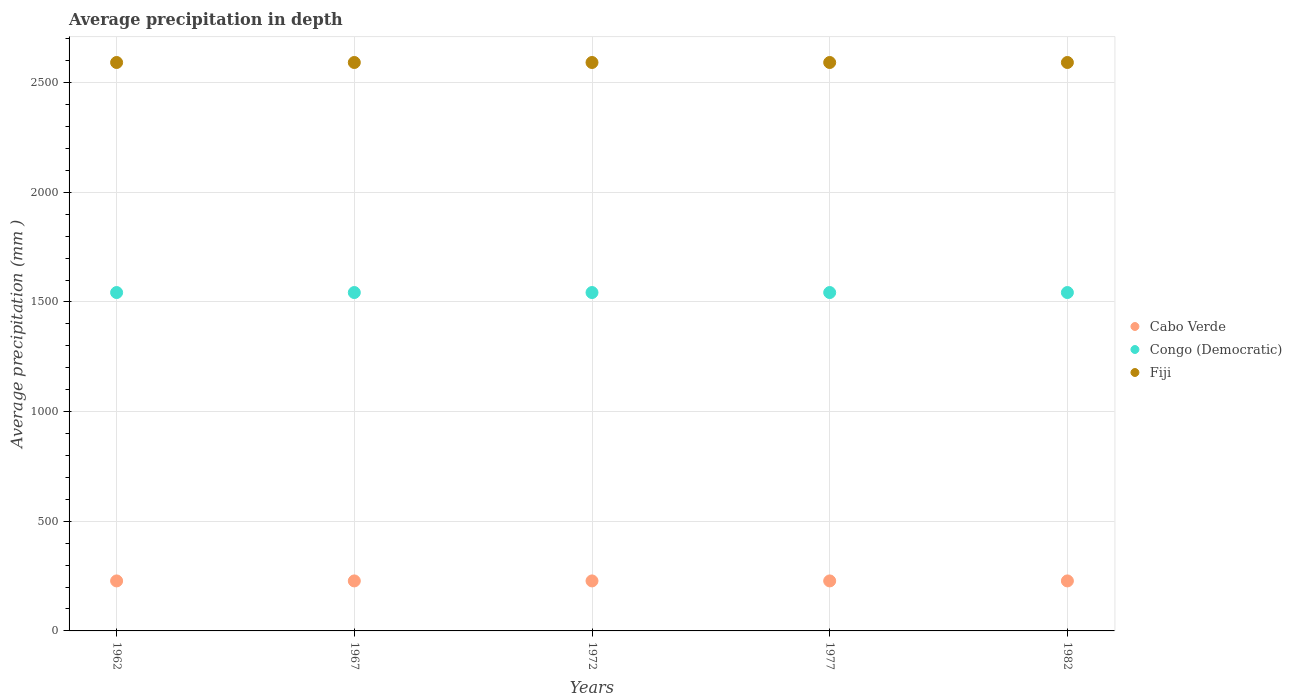What is the average precipitation in Fiji in 1977?
Offer a very short reply. 2592. Across all years, what is the maximum average precipitation in Congo (Democratic)?
Your answer should be very brief. 1543. Across all years, what is the minimum average precipitation in Fiji?
Offer a terse response. 2592. In which year was the average precipitation in Fiji maximum?
Your answer should be very brief. 1962. In which year was the average precipitation in Congo (Democratic) minimum?
Offer a very short reply. 1962. What is the total average precipitation in Congo (Democratic) in the graph?
Ensure brevity in your answer.  7715. What is the difference between the average precipitation in Congo (Democratic) in 1967 and that in 1982?
Keep it short and to the point. 0. What is the difference between the average precipitation in Cabo Verde in 1972 and the average precipitation in Congo (Democratic) in 1982?
Offer a very short reply. -1315. What is the average average precipitation in Cabo Verde per year?
Provide a succinct answer. 228. In the year 1967, what is the difference between the average precipitation in Congo (Democratic) and average precipitation in Fiji?
Ensure brevity in your answer.  -1049. In how many years, is the average precipitation in Cabo Verde greater than 2400 mm?
Offer a terse response. 0. What is the ratio of the average precipitation in Fiji in 1977 to that in 1982?
Your answer should be very brief. 1. Is the average precipitation in Cabo Verde in 1962 less than that in 1972?
Give a very brief answer. No. In how many years, is the average precipitation in Cabo Verde greater than the average average precipitation in Cabo Verde taken over all years?
Your answer should be compact. 0. Is the sum of the average precipitation in Cabo Verde in 1972 and 1982 greater than the maximum average precipitation in Congo (Democratic) across all years?
Your answer should be compact. No. Is the average precipitation in Cabo Verde strictly less than the average precipitation in Congo (Democratic) over the years?
Give a very brief answer. Yes. How many dotlines are there?
Give a very brief answer. 3. What is the difference between two consecutive major ticks on the Y-axis?
Offer a very short reply. 500. Are the values on the major ticks of Y-axis written in scientific E-notation?
Offer a very short reply. No. Does the graph contain any zero values?
Provide a short and direct response. No. Does the graph contain grids?
Provide a succinct answer. Yes. What is the title of the graph?
Your answer should be compact. Average precipitation in depth. What is the label or title of the Y-axis?
Provide a short and direct response. Average precipitation (mm ). What is the Average precipitation (mm ) in Cabo Verde in 1962?
Your answer should be compact. 228. What is the Average precipitation (mm ) of Congo (Democratic) in 1962?
Your answer should be compact. 1543. What is the Average precipitation (mm ) of Fiji in 1962?
Ensure brevity in your answer.  2592. What is the Average precipitation (mm ) in Cabo Verde in 1967?
Give a very brief answer. 228. What is the Average precipitation (mm ) in Congo (Democratic) in 1967?
Make the answer very short. 1543. What is the Average precipitation (mm ) in Fiji in 1967?
Your answer should be very brief. 2592. What is the Average precipitation (mm ) in Cabo Verde in 1972?
Offer a terse response. 228. What is the Average precipitation (mm ) in Congo (Democratic) in 1972?
Your answer should be compact. 1543. What is the Average precipitation (mm ) in Fiji in 1972?
Your answer should be compact. 2592. What is the Average precipitation (mm ) in Cabo Verde in 1977?
Your answer should be compact. 228. What is the Average precipitation (mm ) in Congo (Democratic) in 1977?
Your answer should be compact. 1543. What is the Average precipitation (mm ) in Fiji in 1977?
Offer a terse response. 2592. What is the Average precipitation (mm ) in Cabo Verde in 1982?
Provide a succinct answer. 228. What is the Average precipitation (mm ) in Congo (Democratic) in 1982?
Provide a short and direct response. 1543. What is the Average precipitation (mm ) of Fiji in 1982?
Your response must be concise. 2592. Across all years, what is the maximum Average precipitation (mm ) of Cabo Verde?
Your answer should be compact. 228. Across all years, what is the maximum Average precipitation (mm ) in Congo (Democratic)?
Offer a terse response. 1543. Across all years, what is the maximum Average precipitation (mm ) of Fiji?
Your answer should be compact. 2592. Across all years, what is the minimum Average precipitation (mm ) in Cabo Verde?
Your answer should be compact. 228. Across all years, what is the minimum Average precipitation (mm ) of Congo (Democratic)?
Your answer should be very brief. 1543. Across all years, what is the minimum Average precipitation (mm ) of Fiji?
Give a very brief answer. 2592. What is the total Average precipitation (mm ) of Cabo Verde in the graph?
Provide a short and direct response. 1140. What is the total Average precipitation (mm ) of Congo (Democratic) in the graph?
Give a very brief answer. 7715. What is the total Average precipitation (mm ) in Fiji in the graph?
Provide a short and direct response. 1.30e+04. What is the difference between the Average precipitation (mm ) of Cabo Verde in 1962 and that in 1967?
Keep it short and to the point. 0. What is the difference between the Average precipitation (mm ) in Congo (Democratic) in 1962 and that in 1967?
Provide a succinct answer. 0. What is the difference between the Average precipitation (mm ) in Cabo Verde in 1962 and that in 1972?
Offer a very short reply. 0. What is the difference between the Average precipitation (mm ) in Cabo Verde in 1962 and that in 1977?
Offer a very short reply. 0. What is the difference between the Average precipitation (mm ) of Congo (Democratic) in 1962 and that in 1977?
Provide a short and direct response. 0. What is the difference between the Average precipitation (mm ) of Cabo Verde in 1967 and that in 1972?
Provide a succinct answer. 0. What is the difference between the Average precipitation (mm ) of Congo (Democratic) in 1967 and that in 1972?
Provide a succinct answer. 0. What is the difference between the Average precipitation (mm ) of Fiji in 1967 and that in 1972?
Give a very brief answer. 0. What is the difference between the Average precipitation (mm ) of Cabo Verde in 1967 and that in 1982?
Provide a short and direct response. 0. What is the difference between the Average precipitation (mm ) of Cabo Verde in 1972 and that in 1977?
Your answer should be compact. 0. What is the difference between the Average precipitation (mm ) in Congo (Democratic) in 1972 and that in 1977?
Ensure brevity in your answer.  0. What is the difference between the Average precipitation (mm ) of Fiji in 1972 and that in 1982?
Your answer should be very brief. 0. What is the difference between the Average precipitation (mm ) of Cabo Verde in 1977 and that in 1982?
Provide a short and direct response. 0. What is the difference between the Average precipitation (mm ) in Cabo Verde in 1962 and the Average precipitation (mm ) in Congo (Democratic) in 1967?
Your answer should be very brief. -1315. What is the difference between the Average precipitation (mm ) of Cabo Verde in 1962 and the Average precipitation (mm ) of Fiji in 1967?
Ensure brevity in your answer.  -2364. What is the difference between the Average precipitation (mm ) in Congo (Democratic) in 1962 and the Average precipitation (mm ) in Fiji in 1967?
Give a very brief answer. -1049. What is the difference between the Average precipitation (mm ) of Cabo Verde in 1962 and the Average precipitation (mm ) of Congo (Democratic) in 1972?
Make the answer very short. -1315. What is the difference between the Average precipitation (mm ) of Cabo Verde in 1962 and the Average precipitation (mm ) of Fiji in 1972?
Your answer should be very brief. -2364. What is the difference between the Average precipitation (mm ) in Congo (Democratic) in 1962 and the Average precipitation (mm ) in Fiji in 1972?
Keep it short and to the point. -1049. What is the difference between the Average precipitation (mm ) of Cabo Verde in 1962 and the Average precipitation (mm ) of Congo (Democratic) in 1977?
Offer a terse response. -1315. What is the difference between the Average precipitation (mm ) of Cabo Verde in 1962 and the Average precipitation (mm ) of Fiji in 1977?
Make the answer very short. -2364. What is the difference between the Average precipitation (mm ) in Congo (Democratic) in 1962 and the Average precipitation (mm ) in Fiji in 1977?
Make the answer very short. -1049. What is the difference between the Average precipitation (mm ) of Cabo Verde in 1962 and the Average precipitation (mm ) of Congo (Democratic) in 1982?
Ensure brevity in your answer.  -1315. What is the difference between the Average precipitation (mm ) of Cabo Verde in 1962 and the Average precipitation (mm ) of Fiji in 1982?
Ensure brevity in your answer.  -2364. What is the difference between the Average precipitation (mm ) of Congo (Democratic) in 1962 and the Average precipitation (mm ) of Fiji in 1982?
Offer a very short reply. -1049. What is the difference between the Average precipitation (mm ) of Cabo Verde in 1967 and the Average precipitation (mm ) of Congo (Democratic) in 1972?
Provide a succinct answer. -1315. What is the difference between the Average precipitation (mm ) of Cabo Verde in 1967 and the Average precipitation (mm ) of Fiji in 1972?
Give a very brief answer. -2364. What is the difference between the Average precipitation (mm ) in Congo (Democratic) in 1967 and the Average precipitation (mm ) in Fiji in 1972?
Your answer should be compact. -1049. What is the difference between the Average precipitation (mm ) in Cabo Verde in 1967 and the Average precipitation (mm ) in Congo (Democratic) in 1977?
Offer a terse response. -1315. What is the difference between the Average precipitation (mm ) in Cabo Verde in 1967 and the Average precipitation (mm ) in Fiji in 1977?
Offer a very short reply. -2364. What is the difference between the Average precipitation (mm ) of Congo (Democratic) in 1967 and the Average precipitation (mm ) of Fiji in 1977?
Offer a terse response. -1049. What is the difference between the Average precipitation (mm ) of Cabo Verde in 1967 and the Average precipitation (mm ) of Congo (Democratic) in 1982?
Your answer should be very brief. -1315. What is the difference between the Average precipitation (mm ) in Cabo Verde in 1967 and the Average precipitation (mm ) in Fiji in 1982?
Your answer should be compact. -2364. What is the difference between the Average precipitation (mm ) in Congo (Democratic) in 1967 and the Average precipitation (mm ) in Fiji in 1982?
Your response must be concise. -1049. What is the difference between the Average precipitation (mm ) in Cabo Verde in 1972 and the Average precipitation (mm ) in Congo (Democratic) in 1977?
Provide a short and direct response. -1315. What is the difference between the Average precipitation (mm ) of Cabo Verde in 1972 and the Average precipitation (mm ) of Fiji in 1977?
Your answer should be very brief. -2364. What is the difference between the Average precipitation (mm ) of Congo (Democratic) in 1972 and the Average precipitation (mm ) of Fiji in 1977?
Provide a succinct answer. -1049. What is the difference between the Average precipitation (mm ) of Cabo Verde in 1972 and the Average precipitation (mm ) of Congo (Democratic) in 1982?
Offer a terse response. -1315. What is the difference between the Average precipitation (mm ) in Cabo Verde in 1972 and the Average precipitation (mm ) in Fiji in 1982?
Provide a succinct answer. -2364. What is the difference between the Average precipitation (mm ) in Congo (Democratic) in 1972 and the Average precipitation (mm ) in Fiji in 1982?
Your answer should be very brief. -1049. What is the difference between the Average precipitation (mm ) in Cabo Verde in 1977 and the Average precipitation (mm ) in Congo (Democratic) in 1982?
Keep it short and to the point. -1315. What is the difference between the Average precipitation (mm ) of Cabo Verde in 1977 and the Average precipitation (mm ) of Fiji in 1982?
Provide a short and direct response. -2364. What is the difference between the Average precipitation (mm ) of Congo (Democratic) in 1977 and the Average precipitation (mm ) of Fiji in 1982?
Provide a succinct answer. -1049. What is the average Average precipitation (mm ) in Cabo Verde per year?
Provide a succinct answer. 228. What is the average Average precipitation (mm ) in Congo (Democratic) per year?
Ensure brevity in your answer.  1543. What is the average Average precipitation (mm ) of Fiji per year?
Offer a very short reply. 2592. In the year 1962, what is the difference between the Average precipitation (mm ) of Cabo Verde and Average precipitation (mm ) of Congo (Democratic)?
Give a very brief answer. -1315. In the year 1962, what is the difference between the Average precipitation (mm ) of Cabo Verde and Average precipitation (mm ) of Fiji?
Your response must be concise. -2364. In the year 1962, what is the difference between the Average precipitation (mm ) in Congo (Democratic) and Average precipitation (mm ) in Fiji?
Ensure brevity in your answer.  -1049. In the year 1967, what is the difference between the Average precipitation (mm ) of Cabo Verde and Average precipitation (mm ) of Congo (Democratic)?
Provide a short and direct response. -1315. In the year 1967, what is the difference between the Average precipitation (mm ) of Cabo Verde and Average precipitation (mm ) of Fiji?
Ensure brevity in your answer.  -2364. In the year 1967, what is the difference between the Average precipitation (mm ) of Congo (Democratic) and Average precipitation (mm ) of Fiji?
Give a very brief answer. -1049. In the year 1972, what is the difference between the Average precipitation (mm ) in Cabo Verde and Average precipitation (mm ) in Congo (Democratic)?
Your answer should be compact. -1315. In the year 1972, what is the difference between the Average precipitation (mm ) in Cabo Verde and Average precipitation (mm ) in Fiji?
Provide a succinct answer. -2364. In the year 1972, what is the difference between the Average precipitation (mm ) in Congo (Democratic) and Average precipitation (mm ) in Fiji?
Offer a very short reply. -1049. In the year 1977, what is the difference between the Average precipitation (mm ) in Cabo Verde and Average precipitation (mm ) in Congo (Democratic)?
Make the answer very short. -1315. In the year 1977, what is the difference between the Average precipitation (mm ) of Cabo Verde and Average precipitation (mm ) of Fiji?
Your answer should be compact. -2364. In the year 1977, what is the difference between the Average precipitation (mm ) in Congo (Democratic) and Average precipitation (mm ) in Fiji?
Provide a succinct answer. -1049. In the year 1982, what is the difference between the Average precipitation (mm ) in Cabo Verde and Average precipitation (mm ) in Congo (Democratic)?
Keep it short and to the point. -1315. In the year 1982, what is the difference between the Average precipitation (mm ) of Cabo Verde and Average precipitation (mm ) of Fiji?
Provide a succinct answer. -2364. In the year 1982, what is the difference between the Average precipitation (mm ) in Congo (Democratic) and Average precipitation (mm ) in Fiji?
Offer a very short reply. -1049. What is the ratio of the Average precipitation (mm ) of Fiji in 1962 to that in 1967?
Keep it short and to the point. 1. What is the ratio of the Average precipitation (mm ) in Congo (Democratic) in 1962 to that in 1972?
Provide a short and direct response. 1. What is the ratio of the Average precipitation (mm ) of Fiji in 1962 to that in 1977?
Ensure brevity in your answer.  1. What is the ratio of the Average precipitation (mm ) in Fiji in 1962 to that in 1982?
Your answer should be compact. 1. What is the ratio of the Average precipitation (mm ) in Cabo Verde in 1967 to that in 1972?
Your answer should be compact. 1. What is the ratio of the Average precipitation (mm ) of Fiji in 1967 to that in 1982?
Offer a terse response. 1. What is the ratio of the Average precipitation (mm ) of Congo (Democratic) in 1972 to that in 1977?
Keep it short and to the point. 1. What is the ratio of the Average precipitation (mm ) in Congo (Democratic) in 1972 to that in 1982?
Offer a terse response. 1. What is the ratio of the Average precipitation (mm ) in Fiji in 1972 to that in 1982?
Provide a succinct answer. 1. What is the ratio of the Average precipitation (mm ) of Cabo Verde in 1977 to that in 1982?
Keep it short and to the point. 1. What is the difference between the highest and the second highest Average precipitation (mm ) of Cabo Verde?
Offer a very short reply. 0. What is the difference between the highest and the lowest Average precipitation (mm ) in Cabo Verde?
Your answer should be very brief. 0. What is the difference between the highest and the lowest Average precipitation (mm ) in Fiji?
Ensure brevity in your answer.  0. 